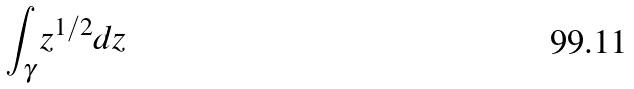<formula> <loc_0><loc_0><loc_500><loc_500>\int _ { \gamma } z ^ { 1 / 2 } d z</formula> 